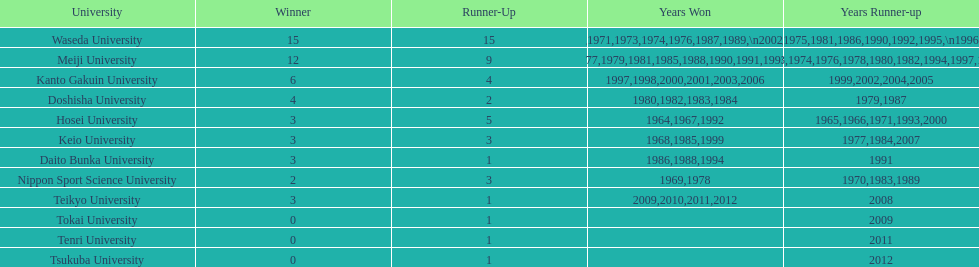Which university has the highest number of winning years? Waseda University. 